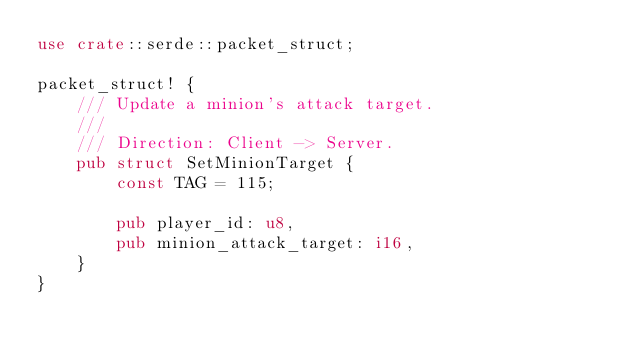<code> <loc_0><loc_0><loc_500><loc_500><_Rust_>use crate::serde::packet_struct;

packet_struct! {
    /// Update a minion's attack target.
    ///
    /// Direction: Client -> Server.
    pub struct SetMinionTarget {
        const TAG = 115;

        pub player_id: u8,
        pub minion_attack_target: i16,
    }
}
</code> 